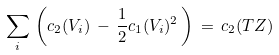<formula> <loc_0><loc_0><loc_500><loc_500>\sum _ { i } \, \left ( c _ { 2 } ( V _ { i } ) \, - \, \frac { 1 } { 2 } c _ { 1 } ( V _ { i } ) ^ { 2 } \, \right ) \, = \, c _ { 2 } ( T Z )</formula> 